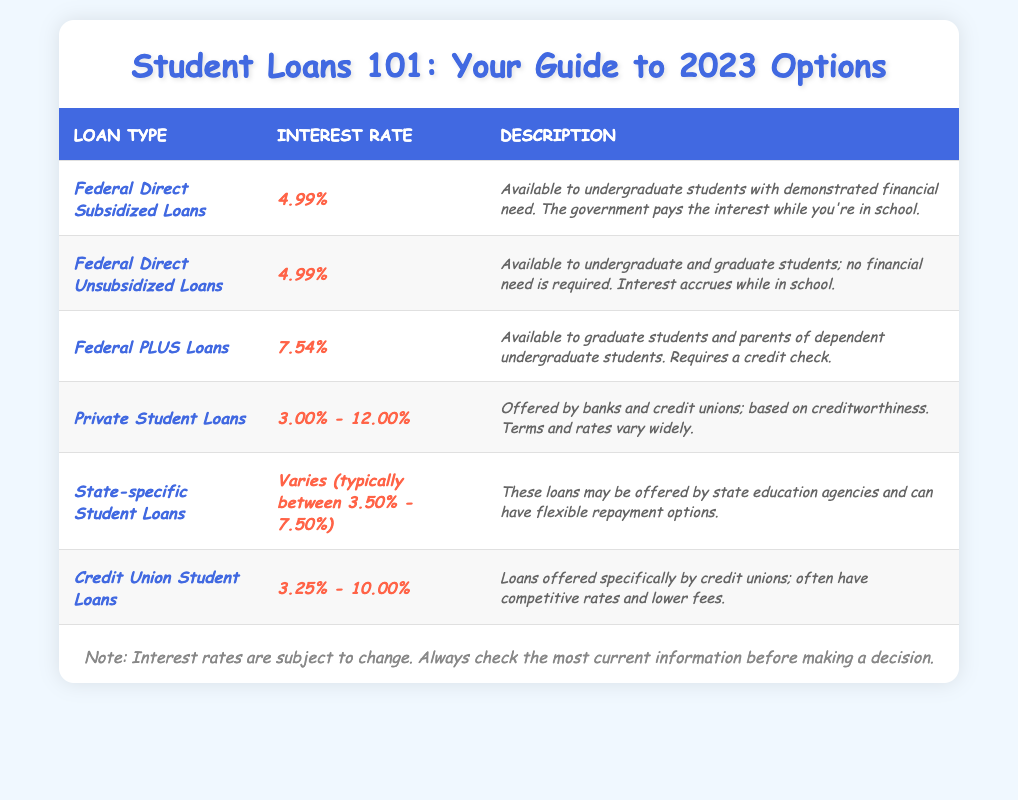What is the interest rate for Federal Direct Subsidized Loans? The table lists the interest rate for Federal Direct Subsidized Loans as 4.99%.
Answer: 4.99% What types of loans are available to graduate students? The table mentions two types of loans available to graduate students: Federal PLUS Loans and Federal Direct Unsubsidized Loans.
Answer: Federal PLUS Loans and Federal Direct Unsubsidized Loans Do Federal Direct Unsubsidized Loans require financial need? The table states that Federal Direct Unsubsidized Loans do not require financial need, so the answer is no.
Answer: No What is the range of interest rates for Private Student Loans? The table provides a range for Private Student Loans' interest rates, which is between 3.00% and 12.00%.
Answer: 3.00% - 12.00% Is the interest rate for Federal PLUS Loans higher than that for Federal Direct Subsidized Loans? The interest rate for Federal PLUS Loans is 7.54%, while the rate for Federal Direct Subsidized Loans is 4.99%. Since 7.54% is greater than 4.99%, the answer is yes.
Answer: Yes What is the average interest rate of State-specific Student Loans and Credit Union Student Loans? For State-specific Student Loans, the typical range is between 3.50% - 7.50%, and for Credit Union Student Loans, it is 3.25% - 10.00%. To find the average, take the midpoints of these ranges: (3.50% + 7.50%) / 2 = 5.50% and (3.25% + 10.00%) / 2 = 6.625%. Then, average these two: (5.50% + 6.625%) / 2 = 6.0625%.
Answer: 6.06% How many types of loans have an interest rate below 5%? From the table, we see that for Federal Direct Subsidized Loans (4.99%), Private Student Loans (3.00% - 12.00%), State-specific Student Loans (3.50% - 7.50%), and Credit Union Student Loans (3.25% - 10.00%), there are 4 types of loans with interest rates starting below 5%.
Answer: 4 Which loan has the highest interest rate? The table indicates that Federal PLUS Loans have the highest interest rate at 7.54%, compared to the other loans listed.
Answer: Federal PLUS Loans What is the total number of loan types listed in the table? The table lists a total of 6 different types of student loans: Federal Direct Subsidized Loans, Federal Direct Unsubsidized Loans, Federal PLUS Loans, Private Student Loans, State-specific Student Loans, and Credit Union Student Loans.
Answer: 6 